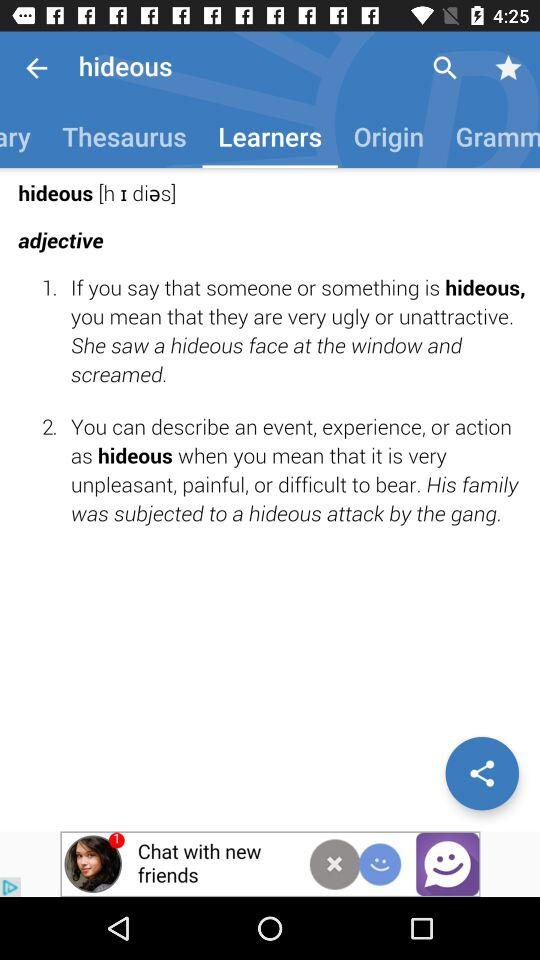Which tab has been selected? The tab that has been selected is "Learners". 